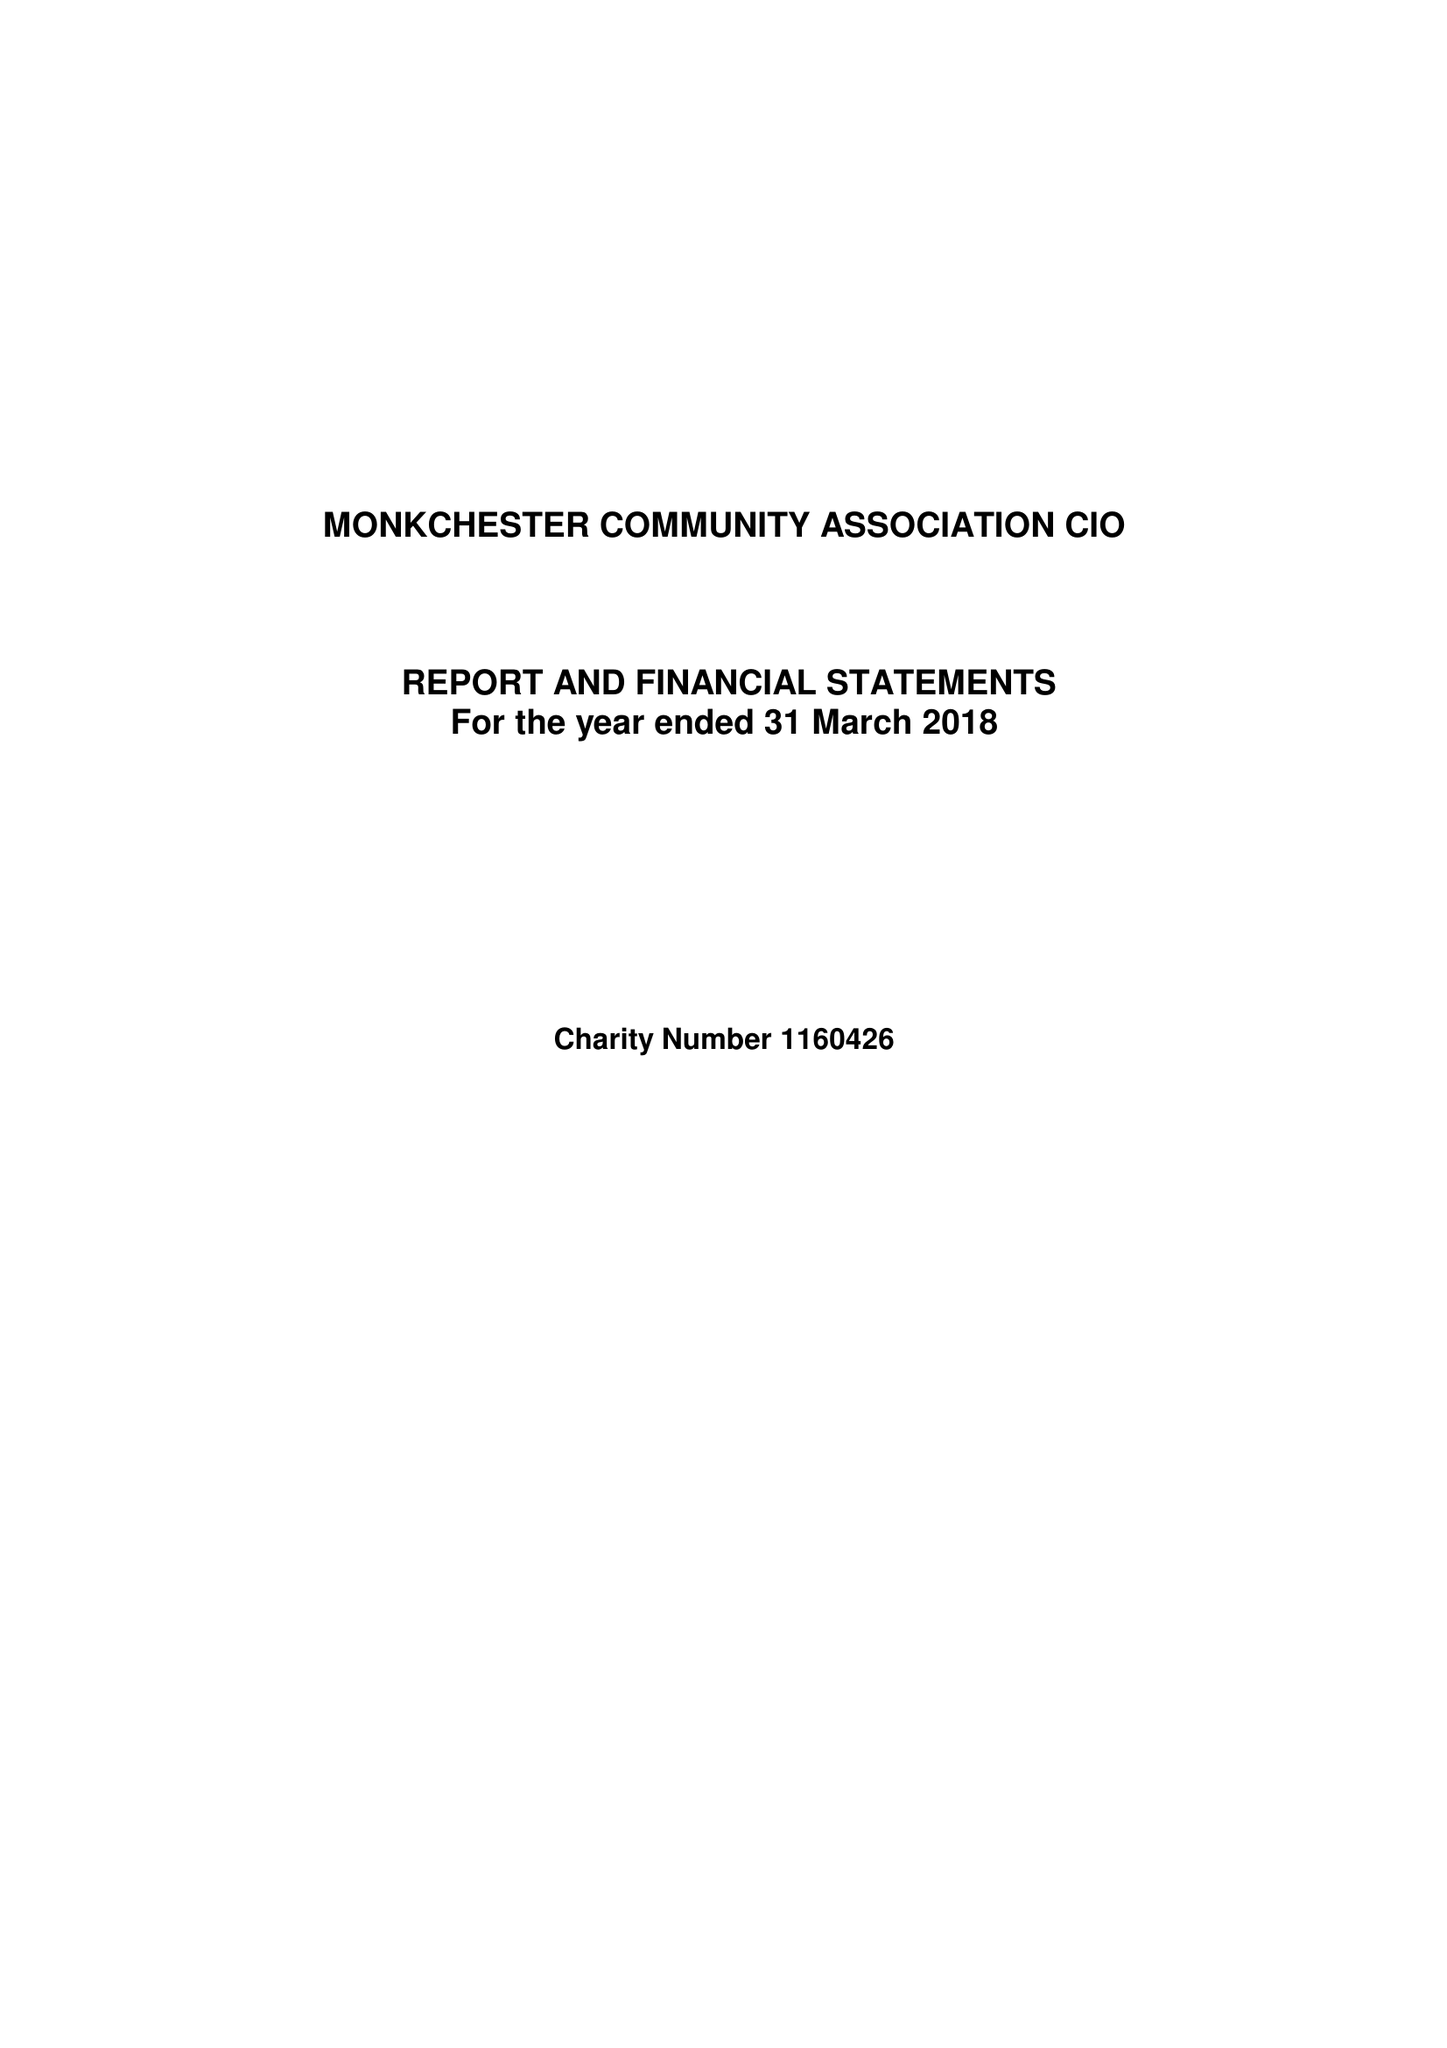What is the value for the address__post_town?
Answer the question using a single word or phrase. NEWCASTLE UPON TYNE 